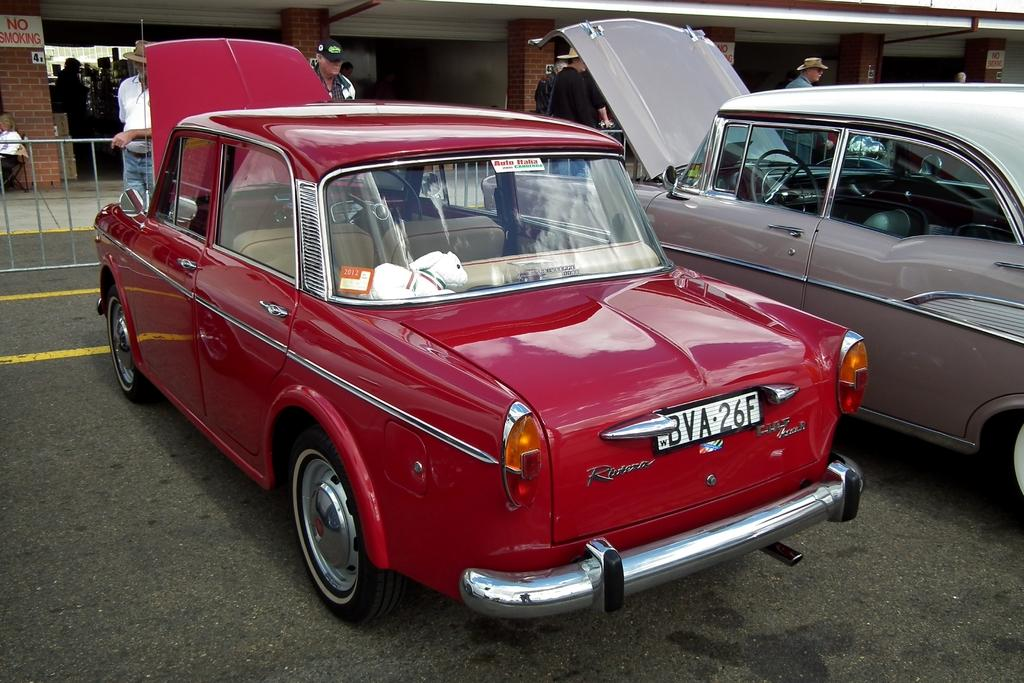What is the main subject in the center of the image? There is a car in the center of the image. Where is the car located? The car is on the road. Are there any other vehicles in the image? Yes, there is another car on the right side of the image. What can be seen in the background of the image? There are persons, fencing, a wall, and a building in the background of the image. What type of canvas is visible on the floor in the image? There is no canvas or floor present in the image; it features a car on the road with a background of various elements. 